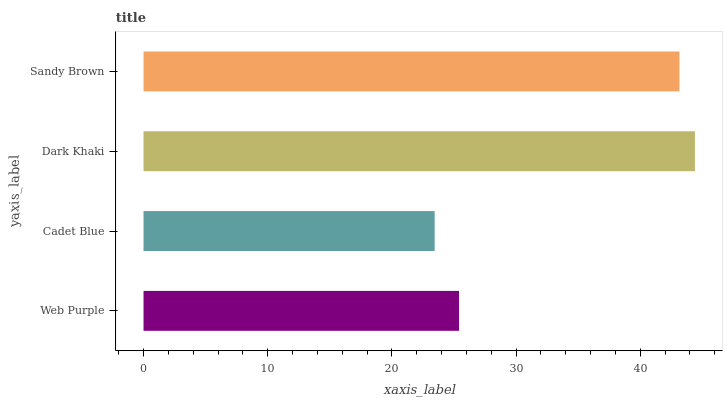Is Cadet Blue the minimum?
Answer yes or no. Yes. Is Dark Khaki the maximum?
Answer yes or no. Yes. Is Dark Khaki the minimum?
Answer yes or no. No. Is Cadet Blue the maximum?
Answer yes or no. No. Is Dark Khaki greater than Cadet Blue?
Answer yes or no. Yes. Is Cadet Blue less than Dark Khaki?
Answer yes or no. Yes. Is Cadet Blue greater than Dark Khaki?
Answer yes or no. No. Is Dark Khaki less than Cadet Blue?
Answer yes or no. No. Is Sandy Brown the high median?
Answer yes or no. Yes. Is Web Purple the low median?
Answer yes or no. Yes. Is Cadet Blue the high median?
Answer yes or no. No. Is Dark Khaki the low median?
Answer yes or no. No. 